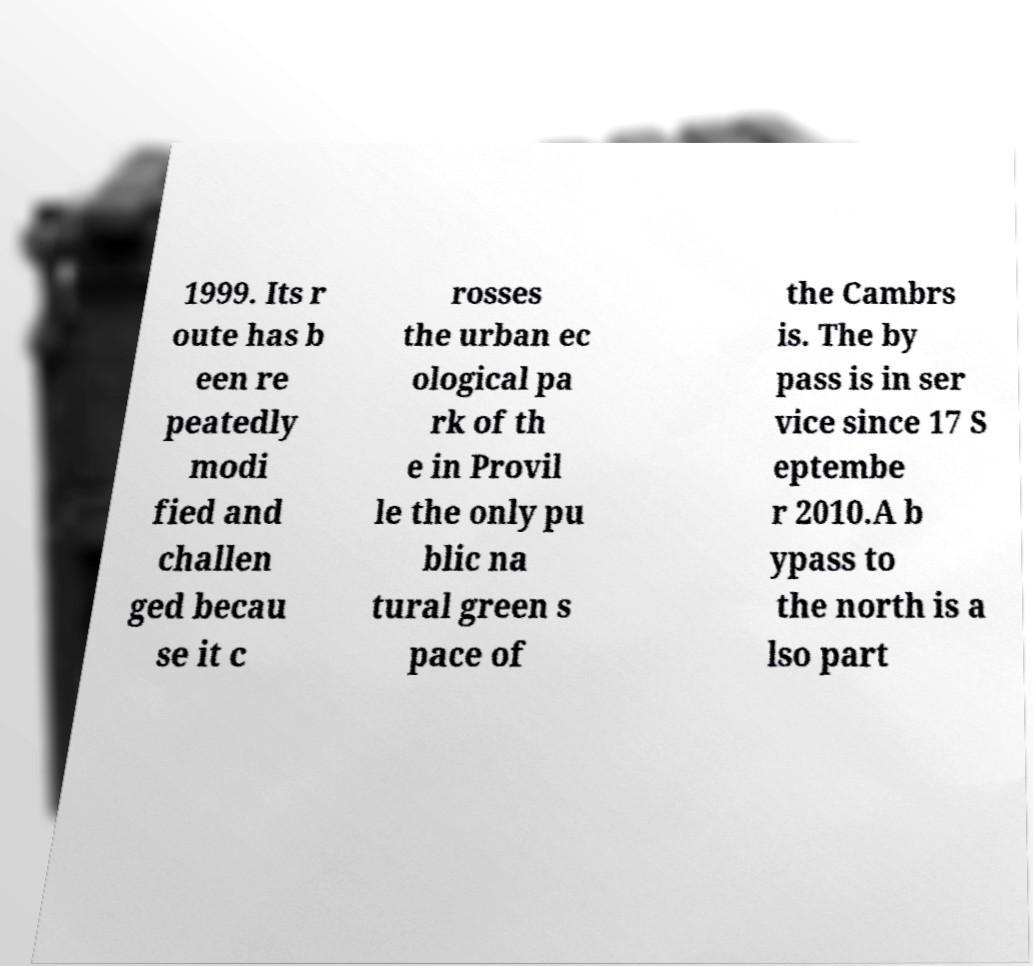What messages or text are displayed in this image? I need them in a readable, typed format. 1999. Its r oute has b een re peatedly modi fied and challen ged becau se it c rosses the urban ec ological pa rk of th e in Provil le the only pu blic na tural green s pace of the Cambrs is. The by pass is in ser vice since 17 S eptembe r 2010.A b ypass to the north is a lso part 